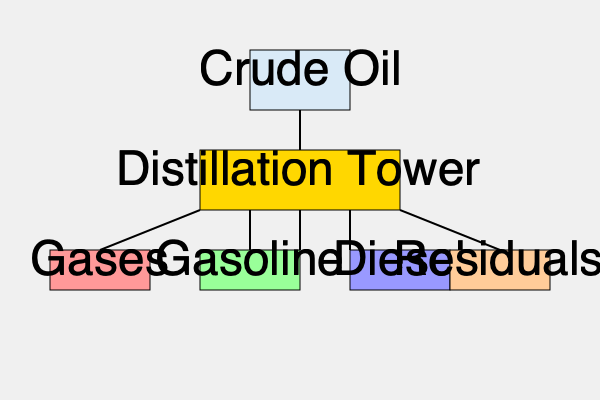In the oil refining process flowchart, which product is typically used as fuel for transportation and has the highest demand in most countries? To answer this question, we need to analyze the oil refining process flowchart and consider the common uses of each product:

1. The flowchart shows crude oil entering the distillation tower, where it is separated into various products based on their boiling points.

2. The products shown in the flowchart are:
   a) Gases
   b) Gasoline
   c) Diesel
   d) Residuals

3. Let's consider each product:
   a) Gases: Typically used for heating or as feedstock for petrochemicals.
   b) Gasoline: Widely used as fuel for passenger vehicles and light-duty trucks.
   c) Diesel: Used for heavy-duty vehicles, some passenger cars, and industrial equipment.
   d) Residuals: Often used for heating oil, ship fuel, or further processed into other products.

4. Among these products, gasoline is the most commonly used fuel for transportation in most countries, especially for personal vehicles.

5. Gasoline has the highest demand in many countries due to the prevalence of gasoline-powered cars and the extensive road transportation network.

6. While diesel is also important for transportation, particularly for trucks and some passenger vehicles, its overall demand is typically lower than gasoline in most countries.

Therefore, based on the flowchart and considering global demand patterns, gasoline is the product that is typically used as fuel for transportation and has the highest demand in most countries.
Answer: Gasoline 